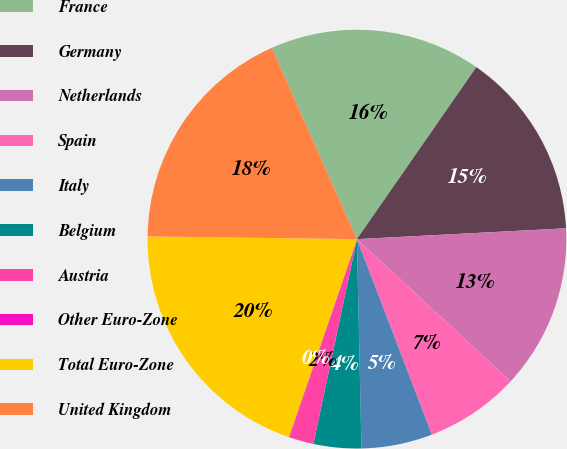Convert chart. <chart><loc_0><loc_0><loc_500><loc_500><pie_chart><fcel>France<fcel>Germany<fcel>Netherlands<fcel>Spain<fcel>Italy<fcel>Belgium<fcel>Austria<fcel>Other Euro-Zone<fcel>Total Euro-Zone<fcel>United Kingdom<nl><fcel>16.32%<fcel>14.52%<fcel>12.71%<fcel>7.29%<fcel>5.48%<fcel>3.68%<fcel>1.87%<fcel>0.06%<fcel>19.94%<fcel>18.13%<nl></chart> 